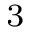Convert formula to latex. <formula><loc_0><loc_0><loc_500><loc_500>_ { 3 }</formula> 